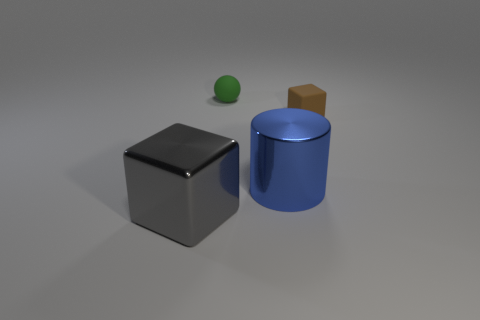There is a big shiny object in front of the blue cylinder; what color is it? The big shiny object in the forefront, which appears to be a gray cube, has a reflective surface that is likely casting various tones and shadows due to the lighting in the environment. 